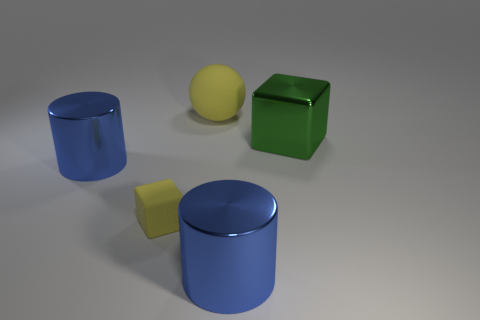What colors are present in the image and what might they signify? The image shows objects in yellow, blue, and green. Yellow often represents energy or attention, blue can evoke calmness or stability, and green typically symbolizes growth or nature. These colors together may provide a visually calming effect with a pop of energy from the yellow sphere. 